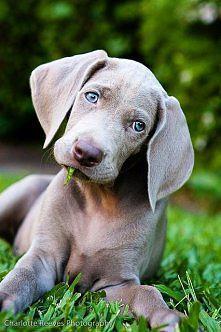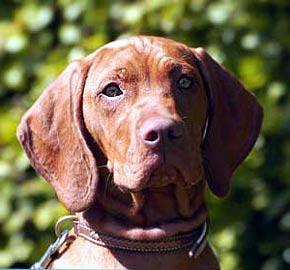The first image is the image on the left, the second image is the image on the right. Analyze the images presented: Is the assertion "One dog is standing." valid? Answer yes or no. No. The first image is the image on the left, the second image is the image on the right. Considering the images on both sides, is "Each image contains a single dog, and the left image features a dog with its head cocked, while the right image shows a dog looking directly forward with a straight head." valid? Answer yes or no. Yes. 